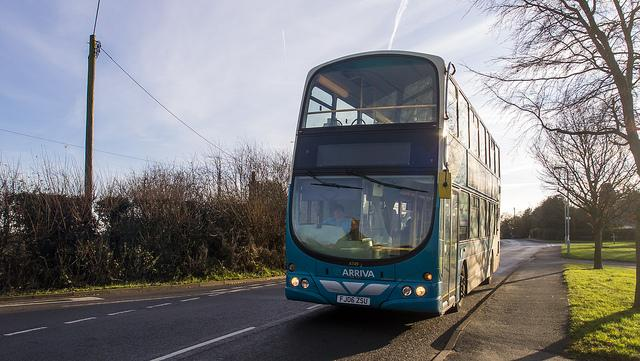How is this bus different from traditional US buses?

Choices:
A) electric
B) double wide
C) windowless
D) double-decker double-decker 